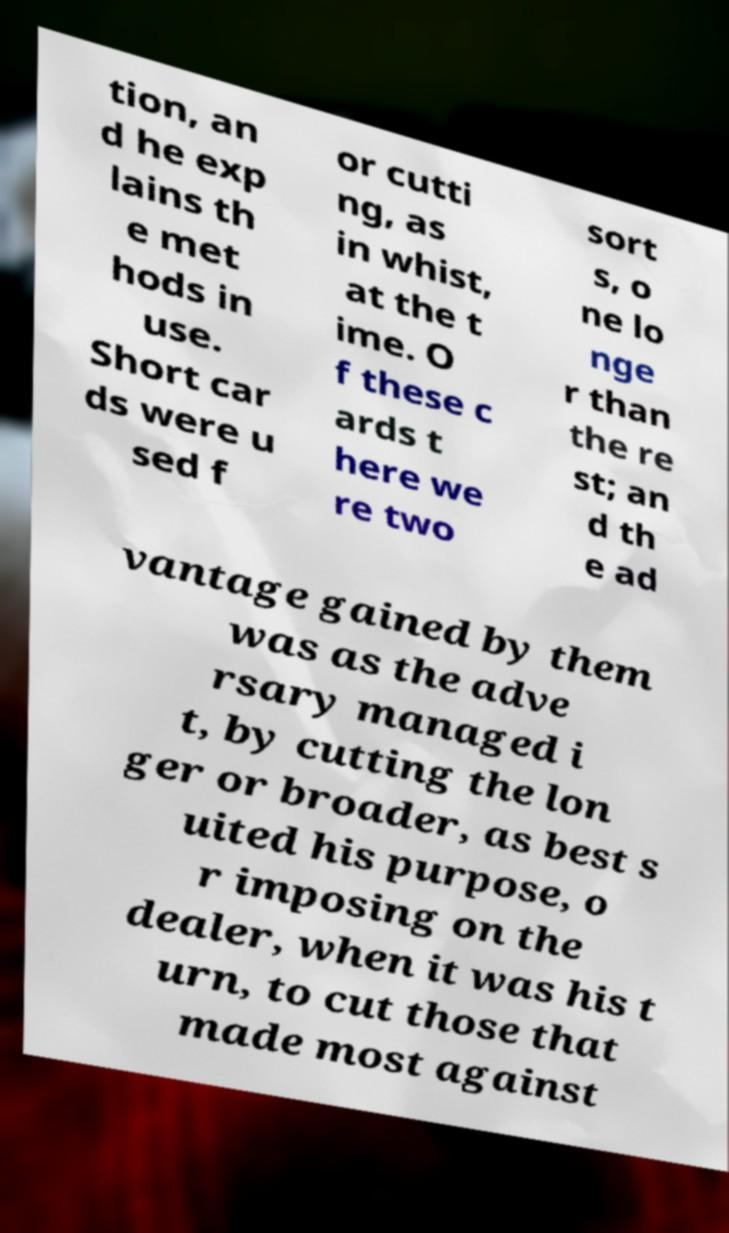Could you assist in decoding the text presented in this image and type it out clearly? tion, an d he exp lains th e met hods in use. Short car ds were u sed f or cutti ng, as in whist, at the t ime. O f these c ards t here we re two sort s, o ne lo nge r than the re st; an d th e ad vantage gained by them was as the adve rsary managed i t, by cutting the lon ger or broader, as best s uited his purpose, o r imposing on the dealer, when it was his t urn, to cut those that made most against 